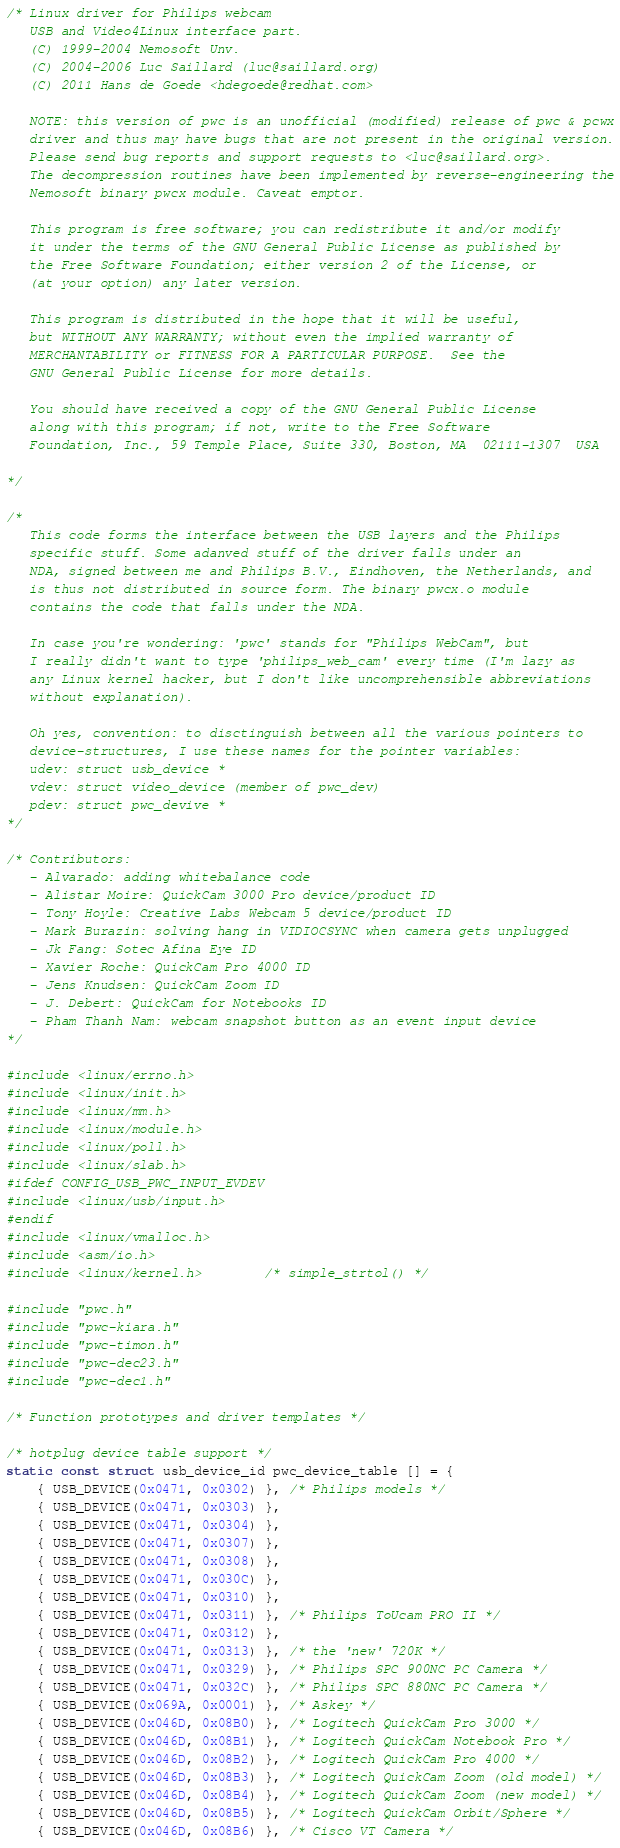Convert code to text. <code><loc_0><loc_0><loc_500><loc_500><_C_>/* Linux driver for Philips webcam
   USB and Video4Linux interface part.
   (C) 1999-2004 Nemosoft Unv.
   (C) 2004-2006 Luc Saillard (luc@saillard.org)
   (C) 2011 Hans de Goede <hdegoede@redhat.com>

   NOTE: this version of pwc is an unofficial (modified) release of pwc & pcwx
   driver and thus may have bugs that are not present in the original version.
   Please send bug reports and support requests to <luc@saillard.org>.
   The decompression routines have been implemented by reverse-engineering the
   Nemosoft binary pwcx module. Caveat emptor.

   This program is free software; you can redistribute it and/or modify
   it under the terms of the GNU General Public License as published by
   the Free Software Foundation; either version 2 of the License, or
   (at your option) any later version.

   This program is distributed in the hope that it will be useful,
   but WITHOUT ANY WARRANTY; without even the implied warranty of
   MERCHANTABILITY or FITNESS FOR A PARTICULAR PURPOSE.  See the
   GNU General Public License for more details.

   You should have received a copy of the GNU General Public License
   along with this program; if not, write to the Free Software
   Foundation, Inc., 59 Temple Place, Suite 330, Boston, MA  02111-1307  USA

*/

/*
   This code forms the interface between the USB layers and the Philips
   specific stuff. Some adanved stuff of the driver falls under an
   NDA, signed between me and Philips B.V., Eindhoven, the Netherlands, and
   is thus not distributed in source form. The binary pwcx.o module
   contains the code that falls under the NDA.

   In case you're wondering: 'pwc' stands for "Philips WebCam", but
   I really didn't want to type 'philips_web_cam' every time (I'm lazy as
   any Linux kernel hacker, but I don't like uncomprehensible abbreviations
   without explanation).

   Oh yes, convention: to disctinguish between all the various pointers to
   device-structures, I use these names for the pointer variables:
   udev: struct usb_device *
   vdev: struct video_device (member of pwc_dev)
   pdev: struct pwc_devive *
*/

/* Contributors:
   - Alvarado: adding whitebalance code
   - Alistar Moire: QuickCam 3000 Pro device/product ID
   - Tony Hoyle: Creative Labs Webcam 5 device/product ID
   - Mark Burazin: solving hang in VIDIOCSYNC when camera gets unplugged
   - Jk Fang: Sotec Afina Eye ID
   - Xavier Roche: QuickCam Pro 4000 ID
   - Jens Knudsen: QuickCam Zoom ID
   - J. Debert: QuickCam for Notebooks ID
   - Pham Thanh Nam: webcam snapshot button as an event input device
*/

#include <linux/errno.h>
#include <linux/init.h>
#include <linux/mm.h>
#include <linux/module.h>
#include <linux/poll.h>
#include <linux/slab.h>
#ifdef CONFIG_USB_PWC_INPUT_EVDEV
#include <linux/usb/input.h>
#endif
#include <linux/vmalloc.h>
#include <asm/io.h>
#include <linux/kernel.h>		/* simple_strtol() */

#include "pwc.h"
#include "pwc-kiara.h"
#include "pwc-timon.h"
#include "pwc-dec23.h"
#include "pwc-dec1.h"

/* Function prototypes and driver templates */

/* hotplug device table support */
static const struct usb_device_id pwc_device_table [] = {
	{ USB_DEVICE(0x0471, 0x0302) }, /* Philips models */
	{ USB_DEVICE(0x0471, 0x0303) },
	{ USB_DEVICE(0x0471, 0x0304) },
	{ USB_DEVICE(0x0471, 0x0307) },
	{ USB_DEVICE(0x0471, 0x0308) },
	{ USB_DEVICE(0x0471, 0x030C) },
	{ USB_DEVICE(0x0471, 0x0310) },
	{ USB_DEVICE(0x0471, 0x0311) }, /* Philips ToUcam PRO II */
	{ USB_DEVICE(0x0471, 0x0312) },
	{ USB_DEVICE(0x0471, 0x0313) }, /* the 'new' 720K */
	{ USB_DEVICE(0x0471, 0x0329) }, /* Philips SPC 900NC PC Camera */
	{ USB_DEVICE(0x0471, 0x032C) }, /* Philips SPC 880NC PC Camera */
	{ USB_DEVICE(0x069A, 0x0001) }, /* Askey */
	{ USB_DEVICE(0x046D, 0x08B0) }, /* Logitech QuickCam Pro 3000 */
	{ USB_DEVICE(0x046D, 0x08B1) }, /* Logitech QuickCam Notebook Pro */
	{ USB_DEVICE(0x046D, 0x08B2) }, /* Logitech QuickCam Pro 4000 */
	{ USB_DEVICE(0x046D, 0x08B3) }, /* Logitech QuickCam Zoom (old model) */
	{ USB_DEVICE(0x046D, 0x08B4) }, /* Logitech QuickCam Zoom (new model) */
	{ USB_DEVICE(0x046D, 0x08B5) }, /* Logitech QuickCam Orbit/Sphere */
	{ USB_DEVICE(0x046D, 0x08B6) }, /* Cisco VT Camera */</code> 